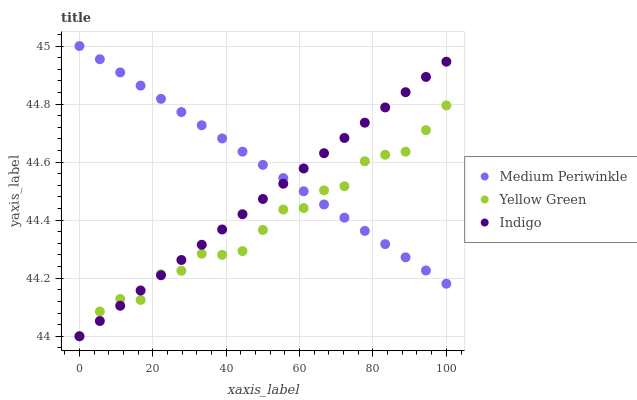Does Yellow Green have the minimum area under the curve?
Answer yes or no. Yes. Does Medium Periwinkle have the maximum area under the curve?
Answer yes or no. Yes. Does Medium Periwinkle have the minimum area under the curve?
Answer yes or no. No. Does Yellow Green have the maximum area under the curve?
Answer yes or no. No. Is Medium Periwinkle the smoothest?
Answer yes or no. Yes. Is Yellow Green the roughest?
Answer yes or no. Yes. Is Yellow Green the smoothest?
Answer yes or no. No. Is Medium Periwinkle the roughest?
Answer yes or no. No. Does Indigo have the lowest value?
Answer yes or no. Yes. Does Medium Periwinkle have the lowest value?
Answer yes or no. No. Does Medium Periwinkle have the highest value?
Answer yes or no. Yes. Does Yellow Green have the highest value?
Answer yes or no. No. Does Indigo intersect Yellow Green?
Answer yes or no. Yes. Is Indigo less than Yellow Green?
Answer yes or no. No. Is Indigo greater than Yellow Green?
Answer yes or no. No. 